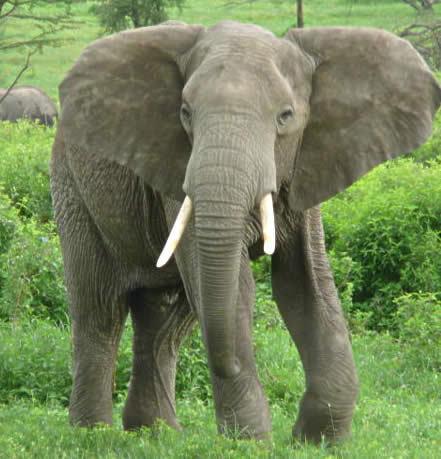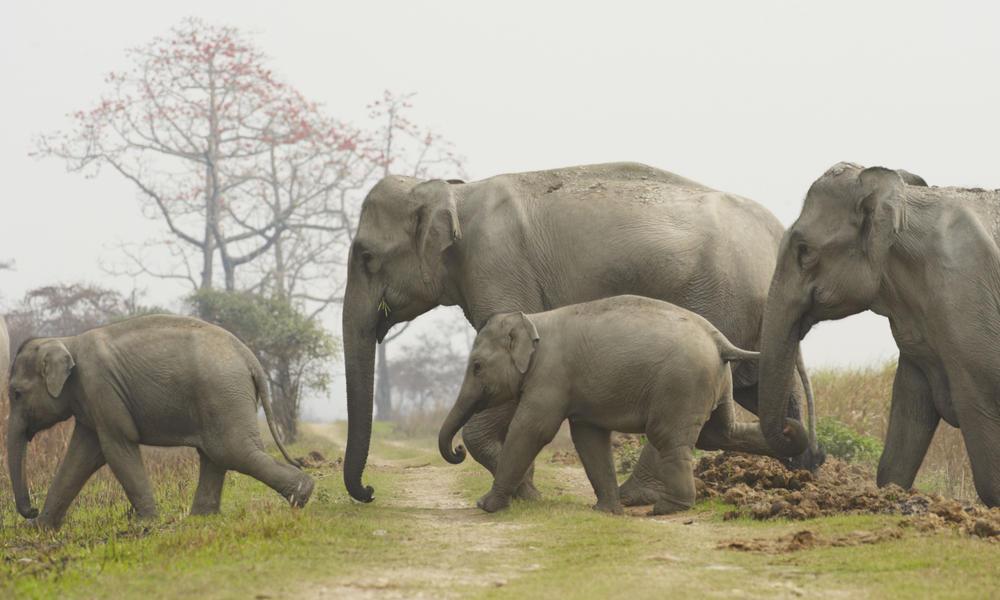The first image is the image on the left, the second image is the image on the right. Given the left and right images, does the statement "The right image shows just one baby elephant next to one adult." hold true? Answer yes or no. No. 